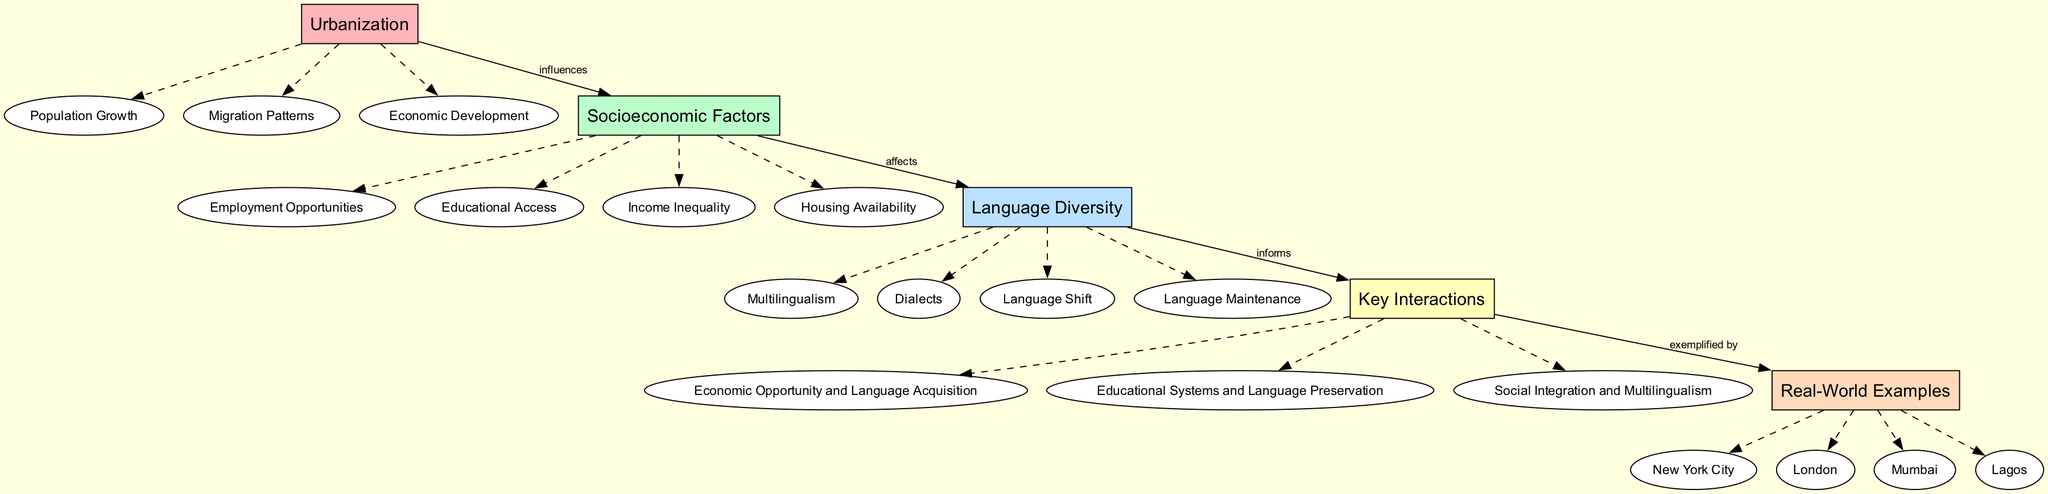What are the sub-elements of Urbanization? The sub-elements of Urbanization are listed directly beneath it in the diagram. They include Population Growth, Migration Patterns, and Economic Development.
Answer: Population Growth, Migration Patterns, Economic Development How many sub-elements are under Socioeconomic Factors? To find this, we count the sub-elements listed below the Socioeconomic Factors node. There are four sub-elements: Employment Opportunities, Educational Access, Income Inequality, and Housing Availability.
Answer: Four What is the relationship between Urbanization and Socioeconomic Factors? The diagram shows a directed edge from Urbanization to Socioeconomic Factors labeled 'influences'. This indicates that Urbanization has an effect on Socioeconomic Factors.
Answer: Influences Which main element affects Language Diversity? The directed edge from Socioeconomic Factors to Language Diversity indicates that Socioeconomic Factors affect Language Diversity.
Answer: Socioeconomic Factors What exemplifies the Key Interactions in the diagram? The directed edge from Key Interactions leads to Real-World Examples, which signifies that Real-World Examples exemplify the Key Interactions presented in the diagram. The examples include New York City, London, Mumbai, and Lagos.
Answer: Real-World Examples How does Economic Opportunity relate to Language Acquisition? Economic Opportunity is part of the Key Interactions that emphasizes its role in Language Acquisition, indicating a positive correlation between access to economic opportunities and success in acquiring languages.
Answer: Economic Opportunity and Language Acquisition Which city is featured as a Real-World Example of urban language diversity? The Real-World Examples sub-elements show specific cities, and one among them is New York City, which serves as an example of the concepts discussed in the diagram.
Answer: New York City What is the total number of main elements in the diagram? By counting the main elements shown in the diagram, we find there are five: Urbanization, Socioeconomic Factors, Language Diversity, Key Interactions, and Real-World Examples.
Answer: Five How many key interactions are listed in the diagram? The Key Interactions section shows three specific interactions: Economic Opportunity and Language Acquisition, Educational Systems and Language Preservation, and Social Integration and Multilingualism. Counting these reveals a total of three.
Answer: Three 